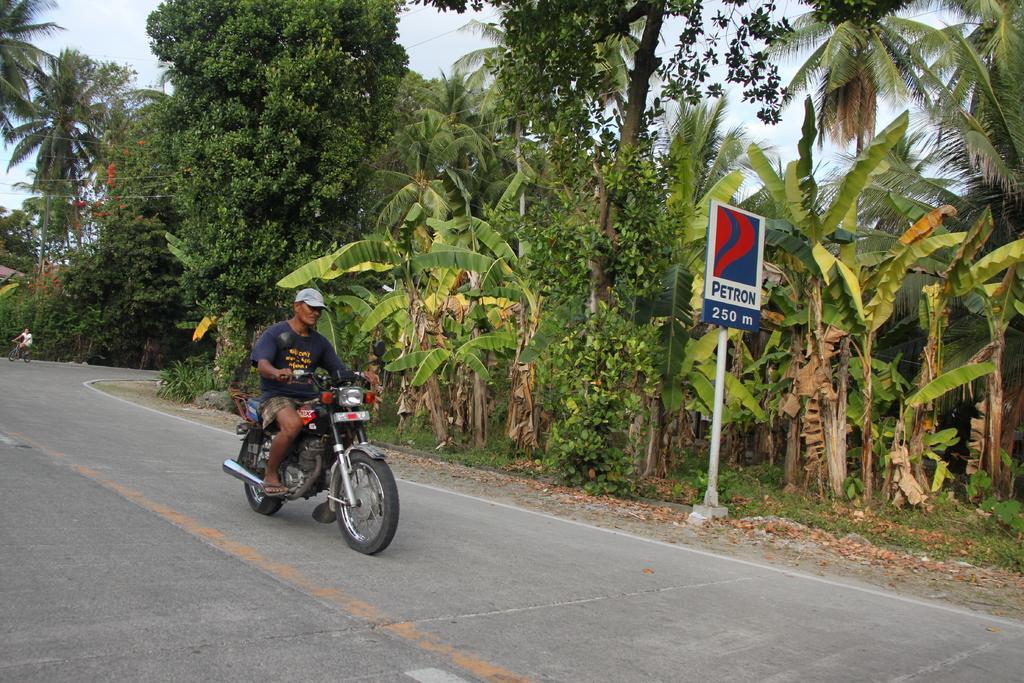Please provide a concise description of this image. The person wearing blue shirt is riding a bike on the road and there are trees beside him and there is another person riding bicycle in the background. 